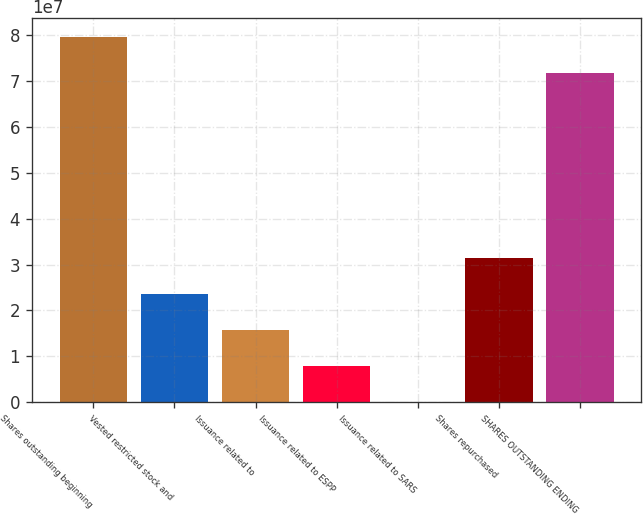<chart> <loc_0><loc_0><loc_500><loc_500><bar_chart><fcel>Shares outstanding beginning<fcel>Vested restricted stock and<fcel>Issuance related to<fcel>Issuance related to ESPP<fcel>Issuance related to SARS<fcel>Shares repurchased<fcel>SHARES OUTSTANDING ENDING<nl><fcel>7.96885e+07<fcel>2.3642e+07<fcel>1.57817e+07<fcel>7.92137e+06<fcel>61070<fcel>3.15023e+07<fcel>7.18282e+07<nl></chart> 